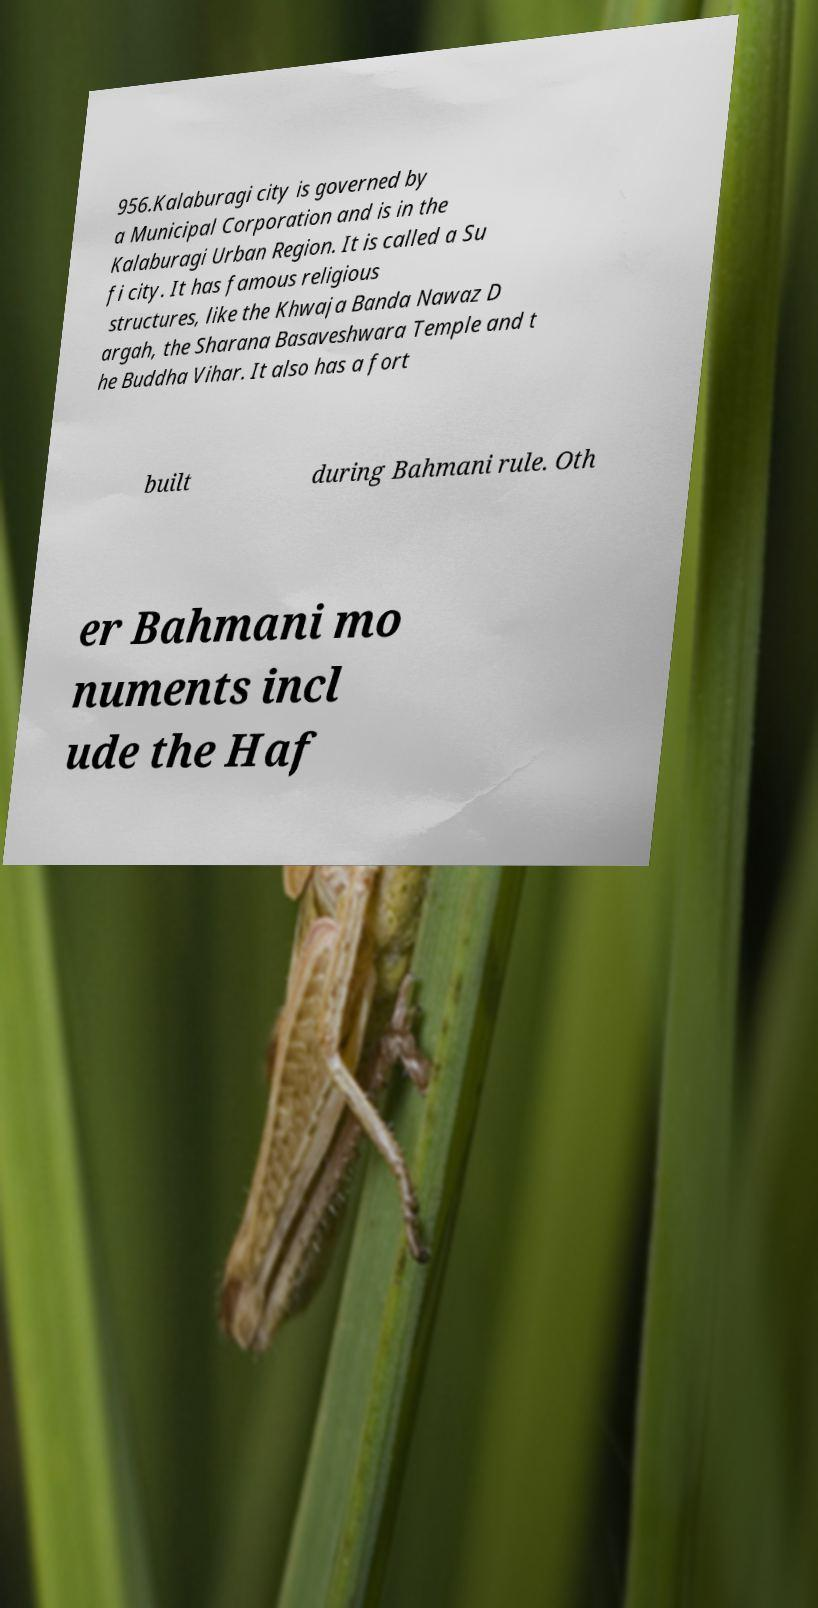Can you accurately transcribe the text from the provided image for me? 956.Kalaburagi city is governed by a Municipal Corporation and is in the Kalaburagi Urban Region. It is called a Su fi city. It has famous religious structures, like the Khwaja Banda Nawaz D argah, the Sharana Basaveshwara Temple and t he Buddha Vihar. It also has a fort built during Bahmani rule. Oth er Bahmani mo numents incl ude the Haf 